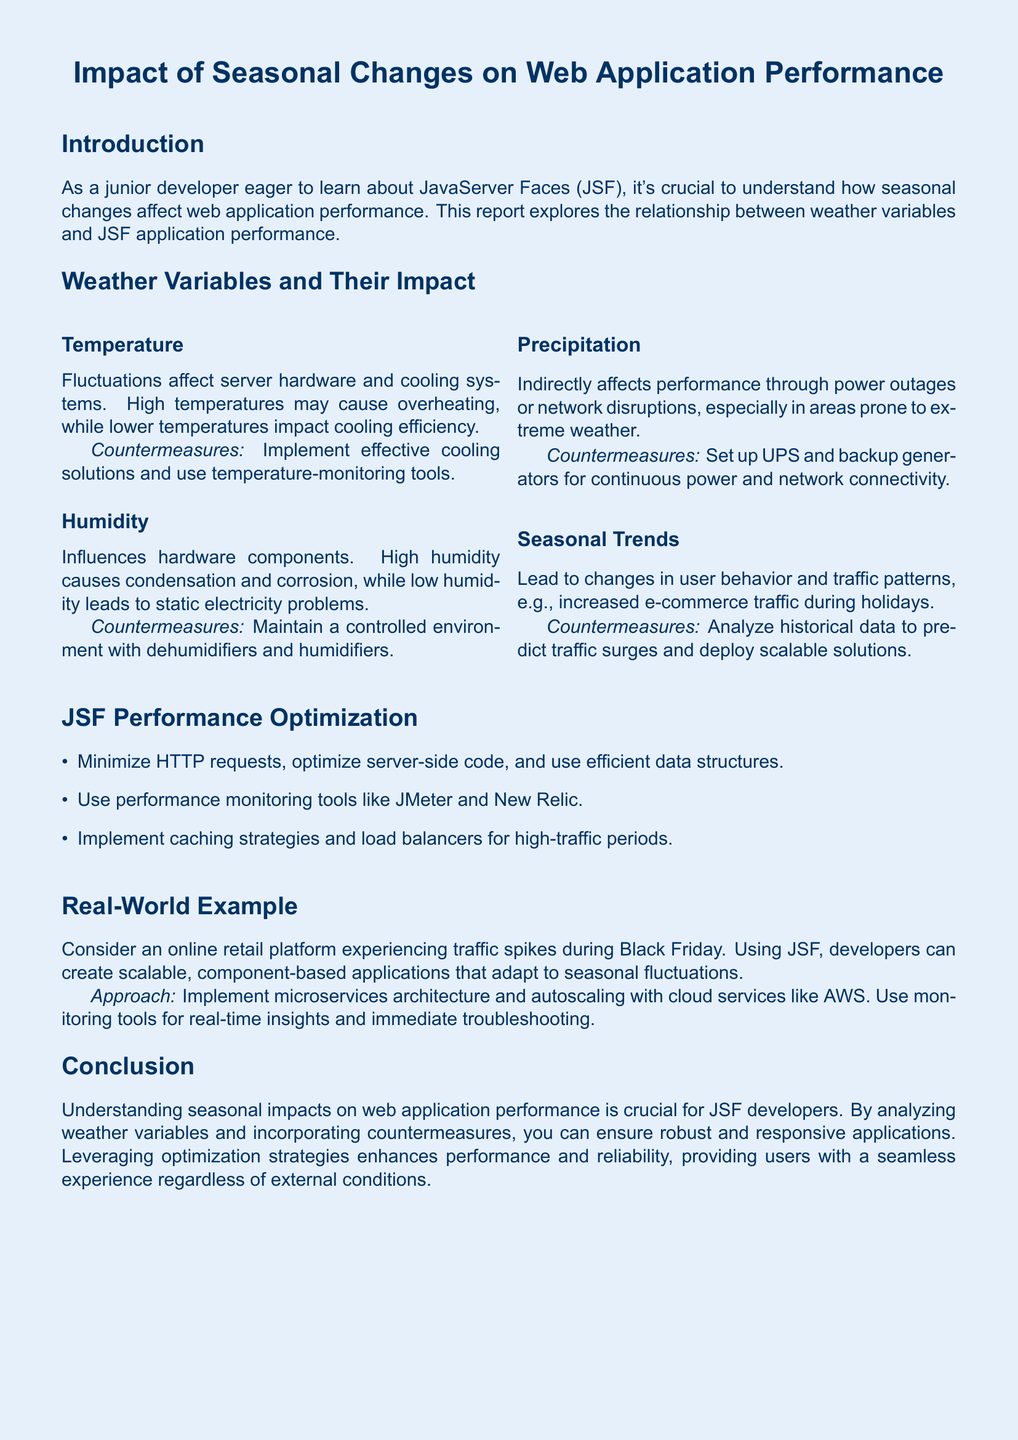What are the two main weather variables affecting web application performance? The document lists temperature and humidity as the two main weather variables influencing performance.
Answer: Temperature and humidity What is a countermeasure for high humidity? The document mentions maintaining a controlled environment with dehumidifiers and humidifiers as a countermeasure for high humidity.
Answer: Dehumidifiers and humidifiers What seasonal trend is noted in the report? The report states that there is increased e-commerce traffic during holidays as a seasonal trend.
Answer: Increased e-commerce traffic Which performance monitoring tools are suggested? The document recommends using JMeter and New Relic as performance monitoring tools.
Answer: JMeter and New Relic What is the approach suggested for handling traffic spikes during Black Friday? The document suggests implementing a microservices architecture and autoscaling with cloud services like AWS for handling traffic spikes.
Answer: Microservices architecture and autoscaling What does UPS stand for in the context of countermeasures? UPS refers to Uninterruptible Power Supply, which is mentioned as a countermeasure against power outages.
Answer: Uninterruptible Power Supply What is the main focus of the report? The report focuses on the impact of seasonal changes on web application performance in relation to JavaServer Faces.
Answer: Seasonal changes on web application performance Which two factors are affected by temperature fluctuations? The document states that server hardware and cooling systems are affected by temperature fluctuations.
Answer: Server hardware and cooling systems How does precipitation indirectly affect performance? According to the document, precipitation affects performance through power outages or network disruptions.
Answer: Power outages or network disruptions 